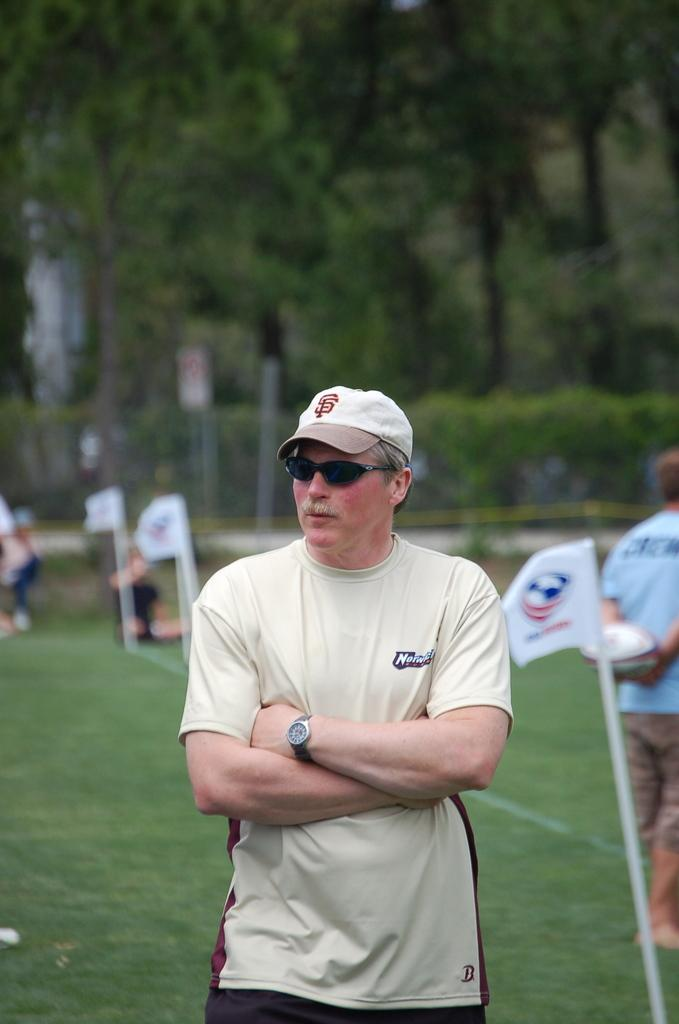What is the main subject of the image? The main subject of the image is a man. Can you describe the man's attire? The man is wearing a cap, spectacles, and a watch. What is the man's position in the image? The man is standing on the ground. What can be seen in the background of the image? There are flags, trees, and other persons in the background of the image. What type of scale is the man using to weigh himself in the image? There is no scale present in the image; the man is simply standing on the ground. Can you tell me the name of the man's sister in the image? There is no mention of a sister or any other family members in the image. 